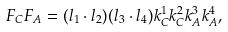<formula> <loc_0><loc_0><loc_500><loc_500>F _ { C } F _ { A } = ( { l _ { 1 } } \cdot { l _ { 2 } } ) ( { l _ { 3 } } \cdot { l _ { 4 } } ) k ^ { 1 } _ { C } k ^ { 2 } _ { C } k ^ { 3 } _ { A } k ^ { 4 } _ { A } ,</formula> 